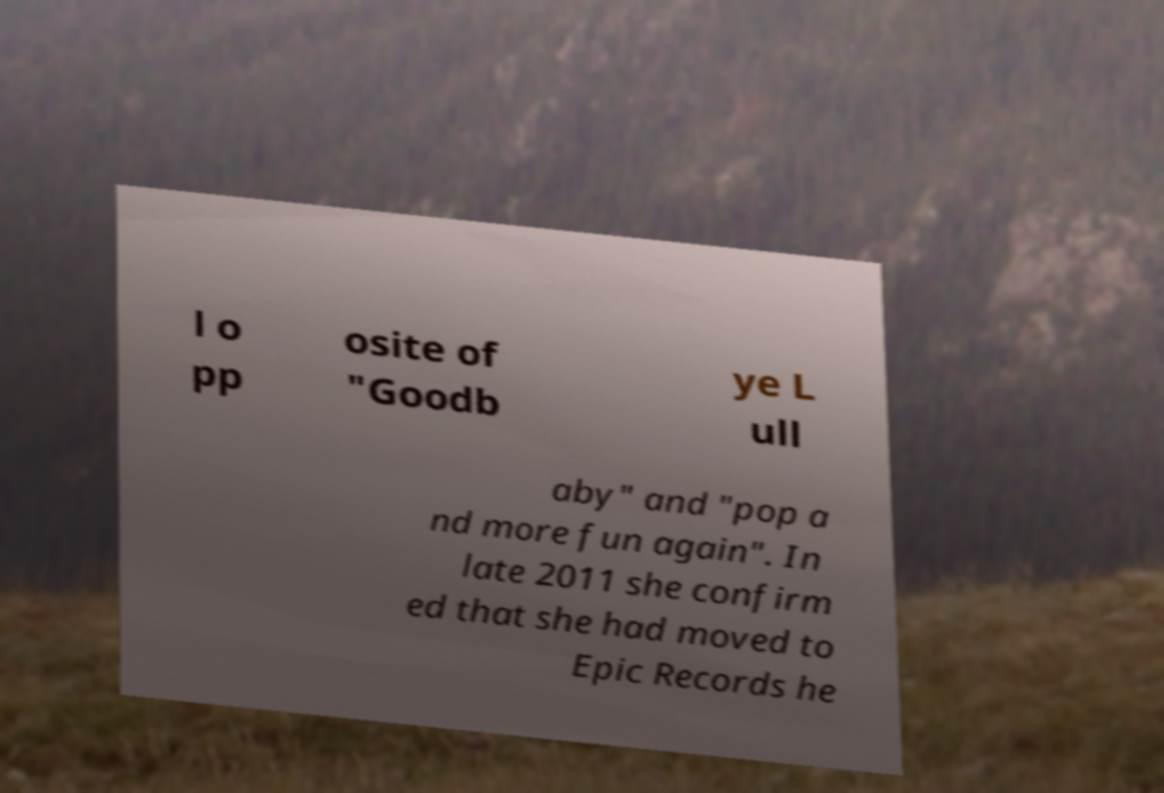Could you assist in decoding the text presented in this image and type it out clearly? l o pp osite of "Goodb ye L ull aby" and "pop a nd more fun again". In late 2011 she confirm ed that she had moved to Epic Records he 